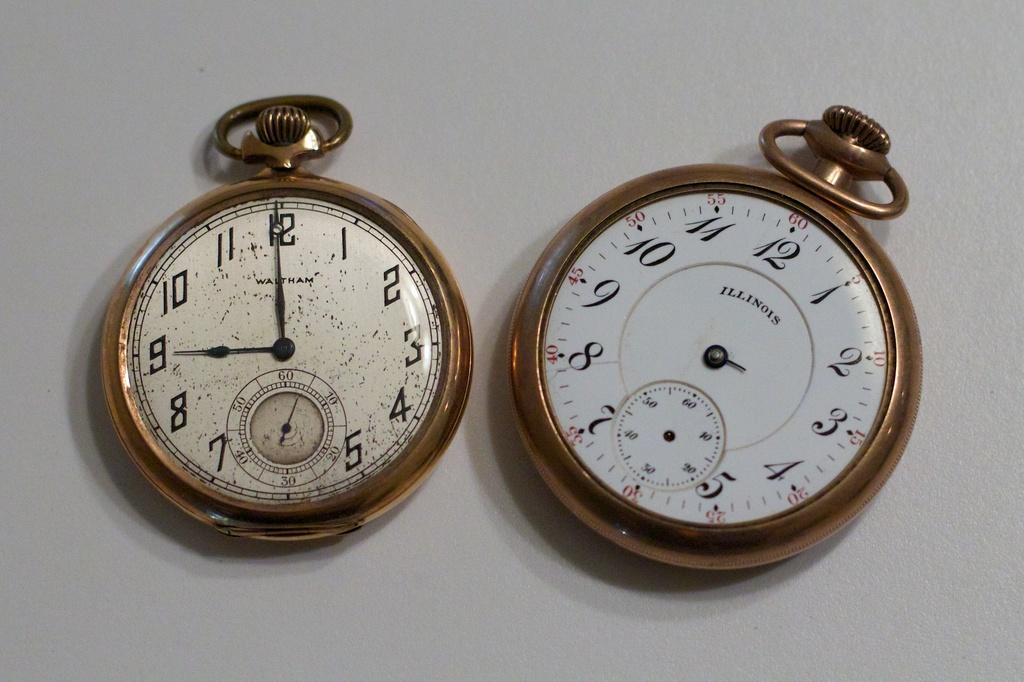<image>
Present a compact description of the photo's key features. Two stop watches right next to one another with one saying Illinois on the face. 